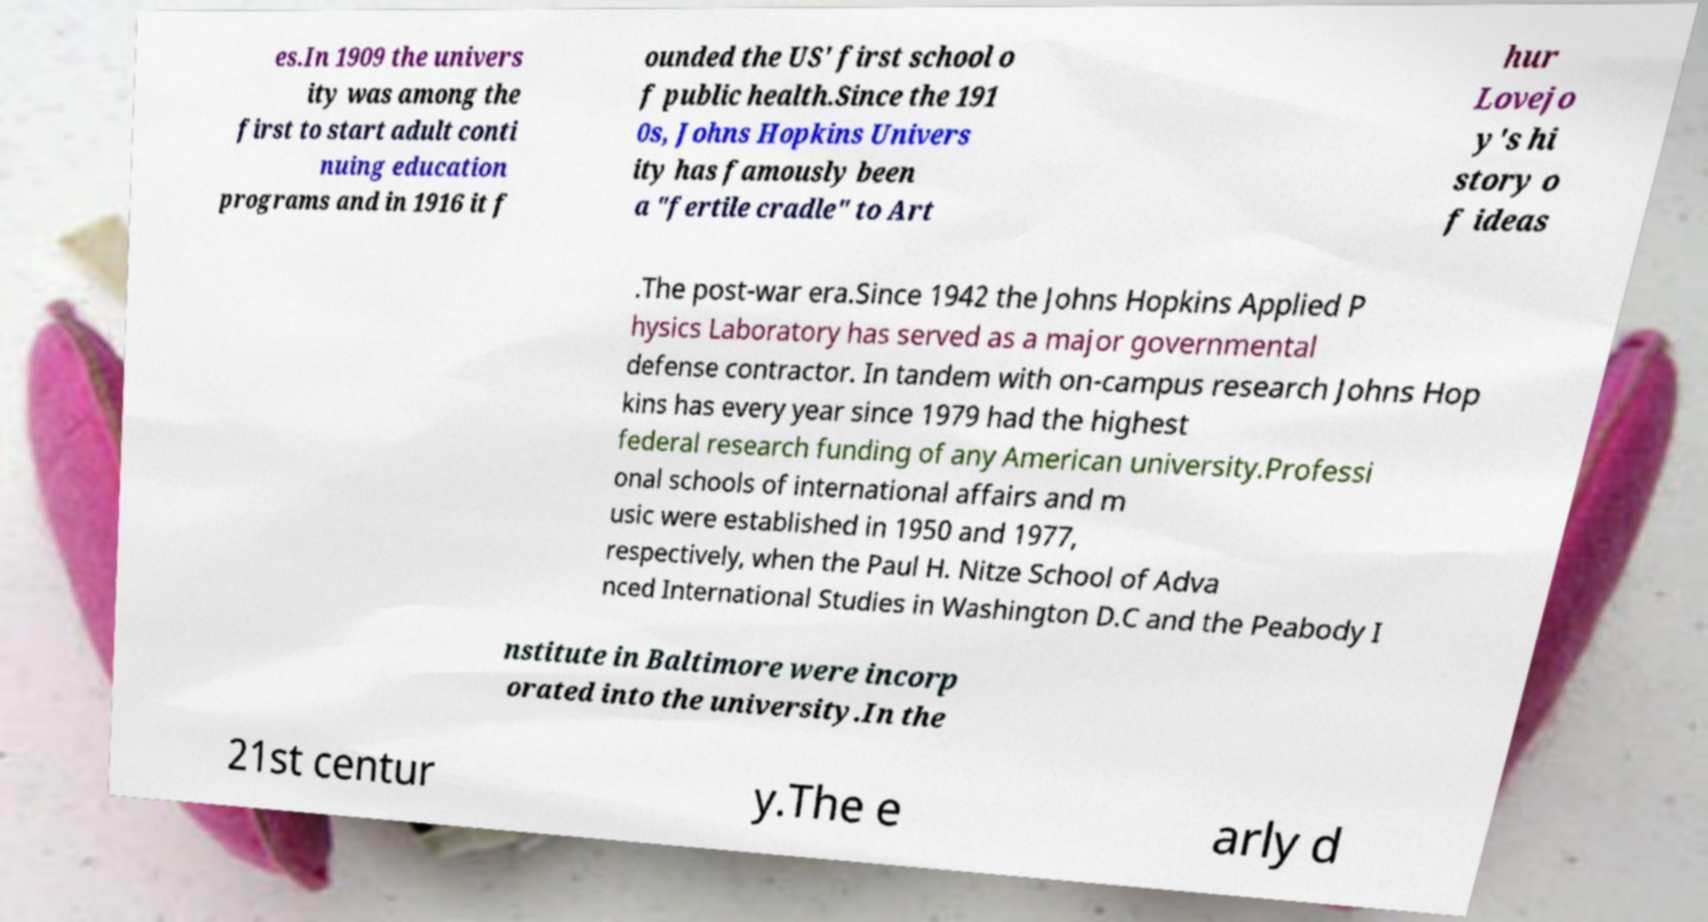For documentation purposes, I need the text within this image transcribed. Could you provide that? es.In 1909 the univers ity was among the first to start adult conti nuing education programs and in 1916 it f ounded the US' first school o f public health.Since the 191 0s, Johns Hopkins Univers ity has famously been a "fertile cradle" to Art hur Lovejo y's hi story o f ideas .The post-war era.Since 1942 the Johns Hopkins Applied P hysics Laboratory has served as a major governmental defense contractor. In tandem with on-campus research Johns Hop kins has every year since 1979 had the highest federal research funding of any American university.Professi onal schools of international affairs and m usic were established in 1950 and 1977, respectively, when the Paul H. Nitze School of Adva nced International Studies in Washington D.C and the Peabody I nstitute in Baltimore were incorp orated into the university.In the 21st centur y.The e arly d 